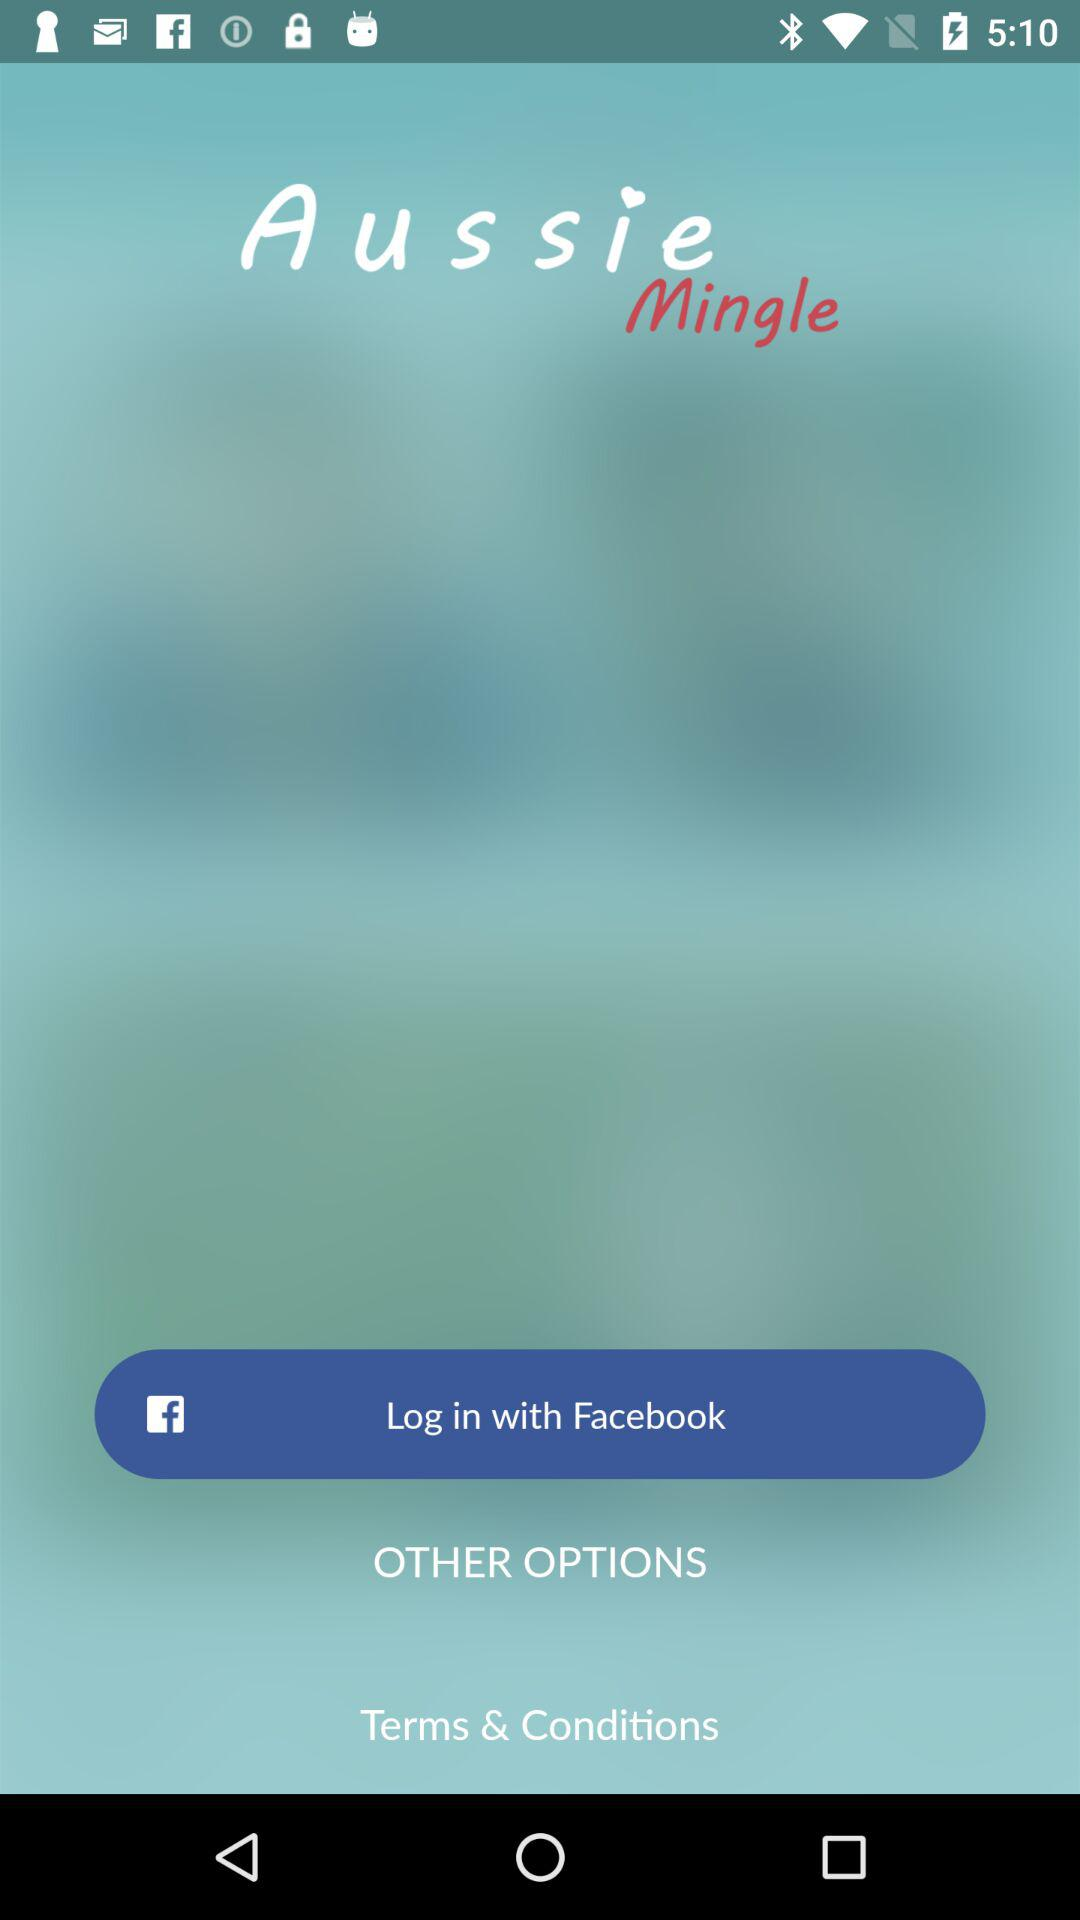What are the options through which we can log in? You can login with Facebook. 